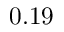<formula> <loc_0><loc_0><loc_500><loc_500>0 . 1 9</formula> 